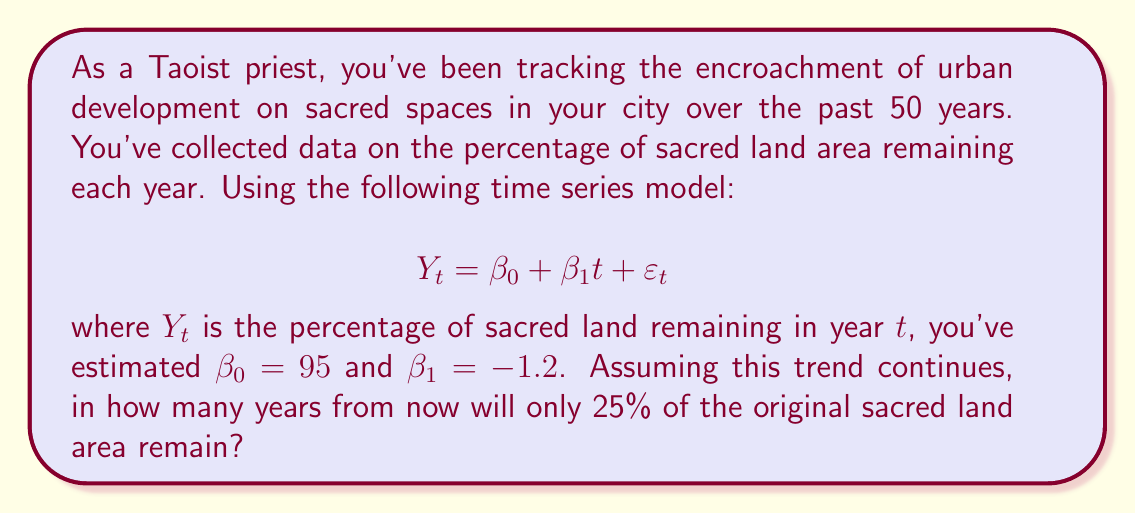Give your solution to this math problem. To solve this problem, we need to use the given time series model and find the time $t$ when $Y_t$ equals 25%. Let's follow these steps:

1) The model is given as: $Y_t = \beta_0 + \beta_1t + \varepsilon_t$

2) We're given that $\beta_0 = 95$ and $\beta_1 = -1.2$

3) We can ignore the error term $\varepsilon_t$ for this prediction

4) Substituting these values, our model becomes:

   $Y_t = 95 - 1.2t$

5) We want to find $t$ when $Y_t = 25$, so we can set up the equation:

   $25 = 95 - 1.2t$

6) Subtract 95 from both sides:

   $-70 = -1.2t$

7) Divide both sides by -1.2:

   $\frac{-70}{-1.2} = t$

8) Simplify:

   $58.33 = t$

9) Since we can't have a fractional year, we round up to the next whole number: 59

Therefore, it will take 59 years from now for only 25% of the original sacred land area to remain, assuming the current trend continues.
Answer: 59 years 